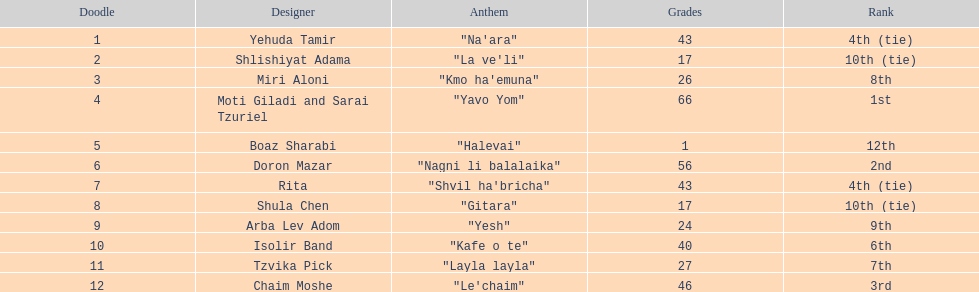What song earned the most points? "Yavo Yom". Would you be able to parse every entry in this table? {'header': ['Doodle', 'Designer', 'Anthem', 'Grades', 'Rank'], 'rows': [['1', 'Yehuda Tamir', '"Na\'ara"', '43', '4th (tie)'], ['2', 'Shlishiyat Adama', '"La ve\'li"', '17', '10th (tie)'], ['3', 'Miri Aloni', '"Kmo ha\'emuna"', '26', '8th'], ['4', 'Moti Giladi and Sarai Tzuriel', '"Yavo Yom"', '66', '1st'], ['5', 'Boaz Sharabi', '"Halevai"', '1', '12th'], ['6', 'Doron Mazar', '"Nagni li balalaika"', '56', '2nd'], ['7', 'Rita', '"Shvil ha\'bricha"', '43', '4th (tie)'], ['8', 'Shula Chen', '"Gitara"', '17', '10th (tie)'], ['9', 'Arba Lev Adom', '"Yesh"', '24', '9th'], ['10', 'Isolir Band', '"Kafe o te"', '40', '6th'], ['11', 'Tzvika Pick', '"Layla layla"', '27', '7th'], ['12', 'Chaim Moshe', '"Le\'chaim"', '46', '3rd']]} 